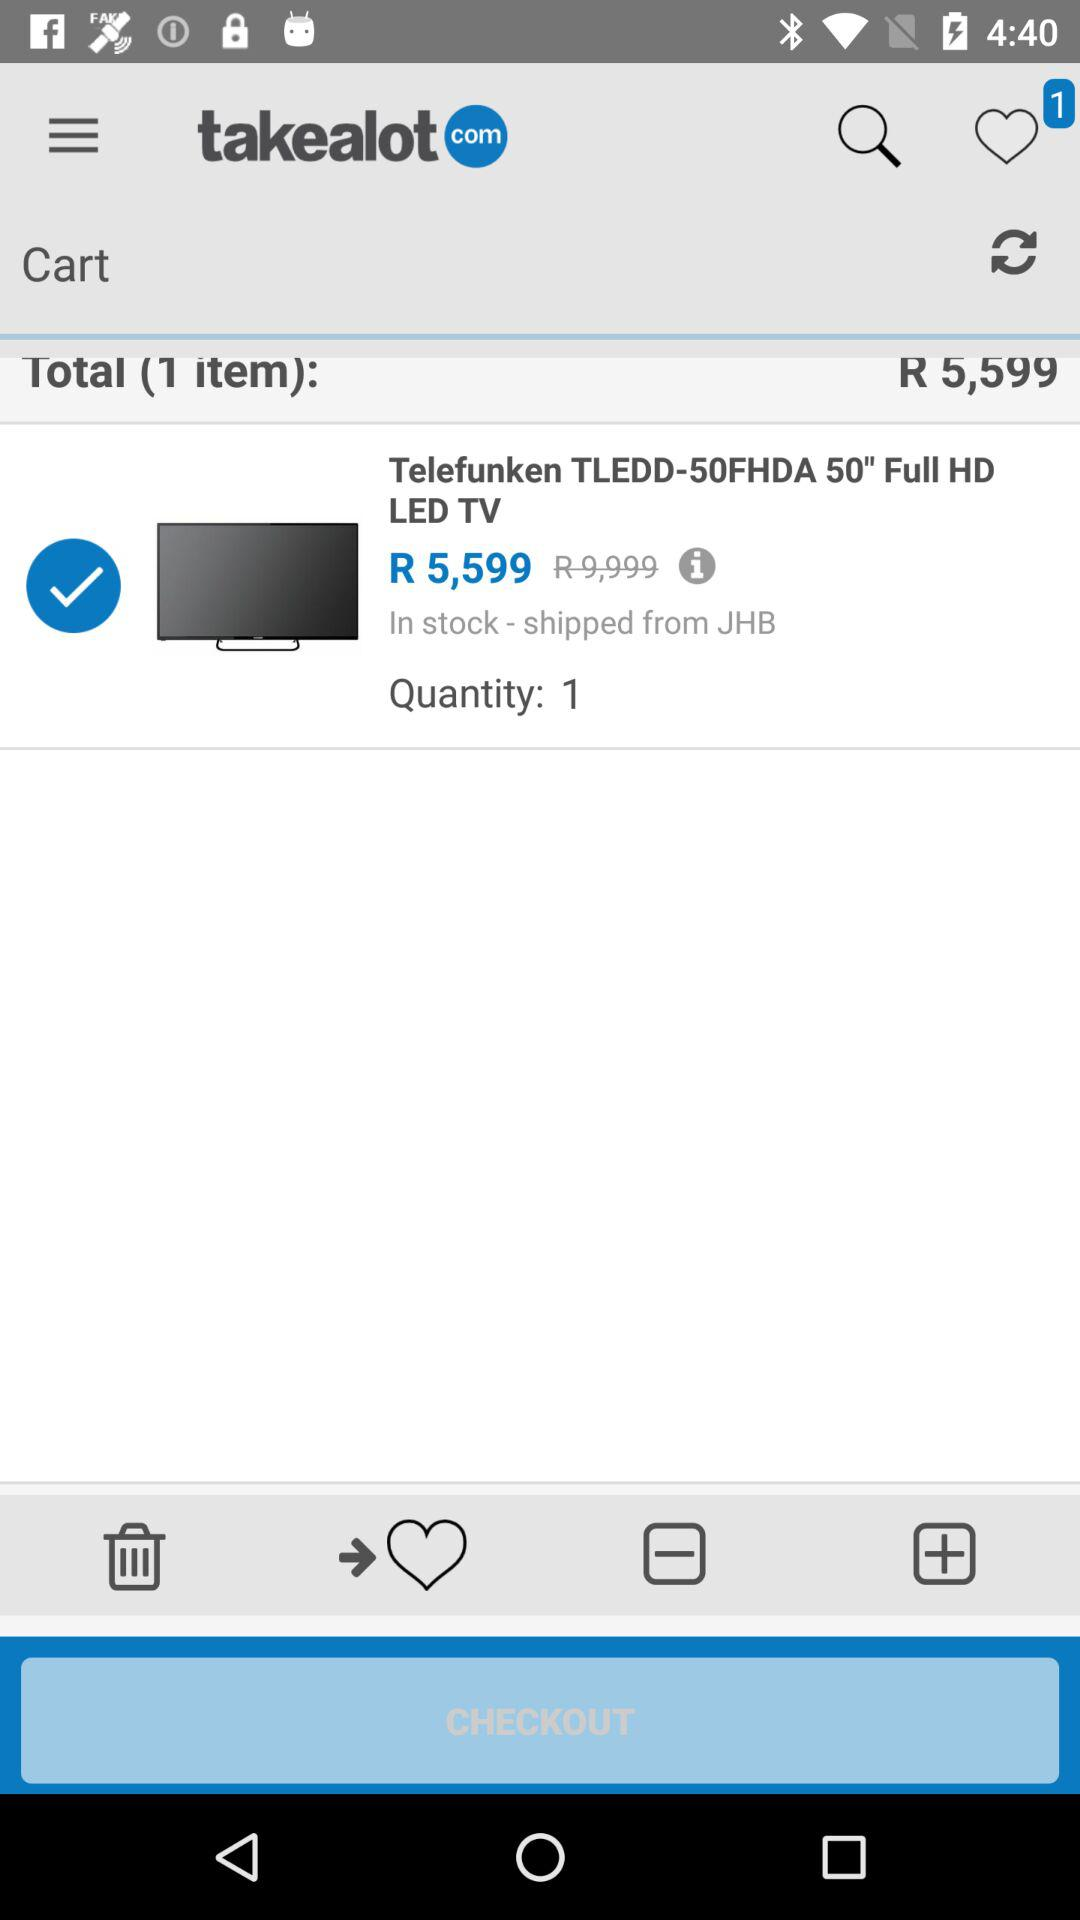How many items are in the cart?
Answer the question using a single word or phrase. 1 